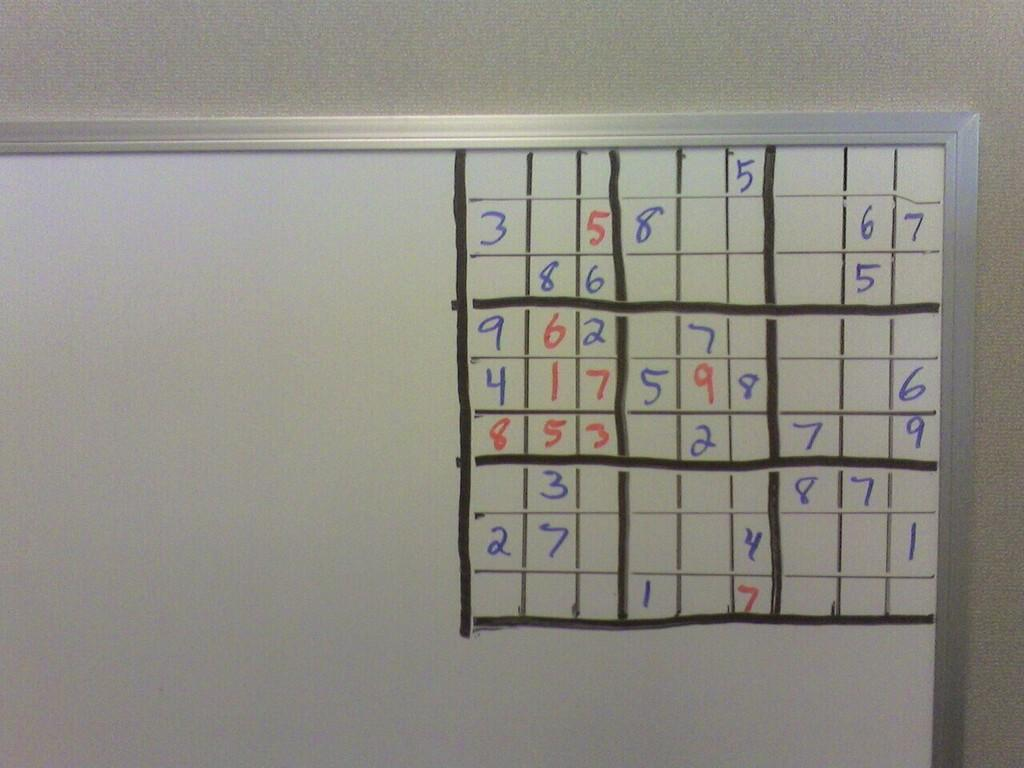Provide a one-sentence caption for the provided image. Sudoku boxes being filled in on a board with a number 3 being the top left most number. 